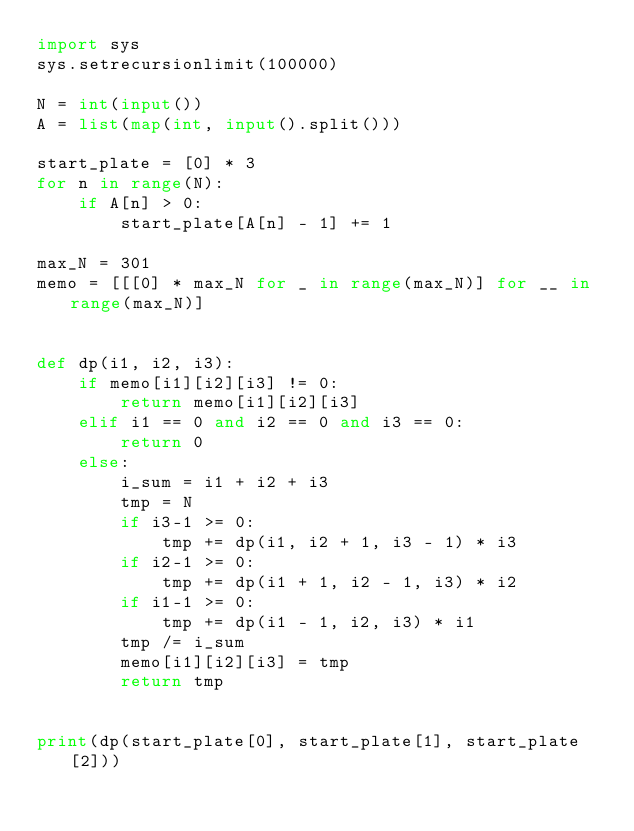Convert code to text. <code><loc_0><loc_0><loc_500><loc_500><_Python_>import sys
sys.setrecursionlimit(100000)

N = int(input())
A = list(map(int, input().split()))

start_plate = [0] * 3
for n in range(N):
    if A[n] > 0:
        start_plate[A[n] - 1] += 1

max_N = 301
memo = [[[0] * max_N for _ in range(max_N)] for __ in range(max_N)]


def dp(i1, i2, i3):
    if memo[i1][i2][i3] != 0:
        return memo[i1][i2][i3]
    elif i1 == 0 and i2 == 0 and i3 == 0:
        return 0
    else:
        i_sum = i1 + i2 + i3
        tmp = N
        if i3-1 >= 0:
            tmp += dp(i1, i2 + 1, i3 - 1) * i3
        if i2-1 >= 0:
            tmp += dp(i1 + 1, i2 - 1, i3) * i2
        if i1-1 >= 0:
            tmp += dp(i1 - 1, i2, i3) * i1
        tmp /= i_sum
        memo[i1][i2][i3] = tmp
        return tmp


print(dp(start_plate[0], start_plate[1], start_plate[2]))</code> 